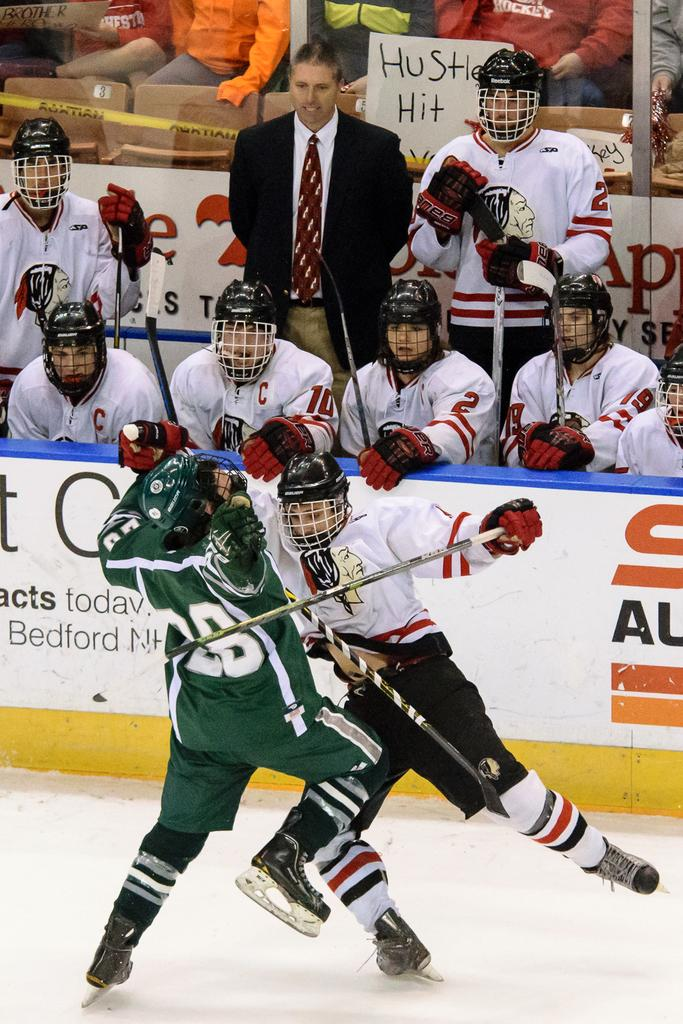What sport are the two men in the image participating in? The two men in the image are playing hockey. What type of footwear are the men wearing? The men are wearing skate shoes. Can you describe the scene in the background of the image? There are many people in the background of the image, both sitting and standing. What type of cave can be seen in the background of the image? There is no cave present in the image; it features two men playing hockey and a background with people sitting and standing. 